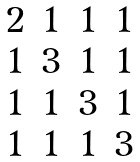<formula> <loc_0><loc_0><loc_500><loc_500>\begin{matrix} 2 & 1 & 1 & 1 \\ 1 & 3 & 1 & 1 \\ 1 & 1 & 3 & 1 \\ 1 & 1 & 1 & 3 \end{matrix}</formula> 